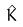<formula> <loc_0><loc_0><loc_500><loc_500>\hat { K }</formula> 